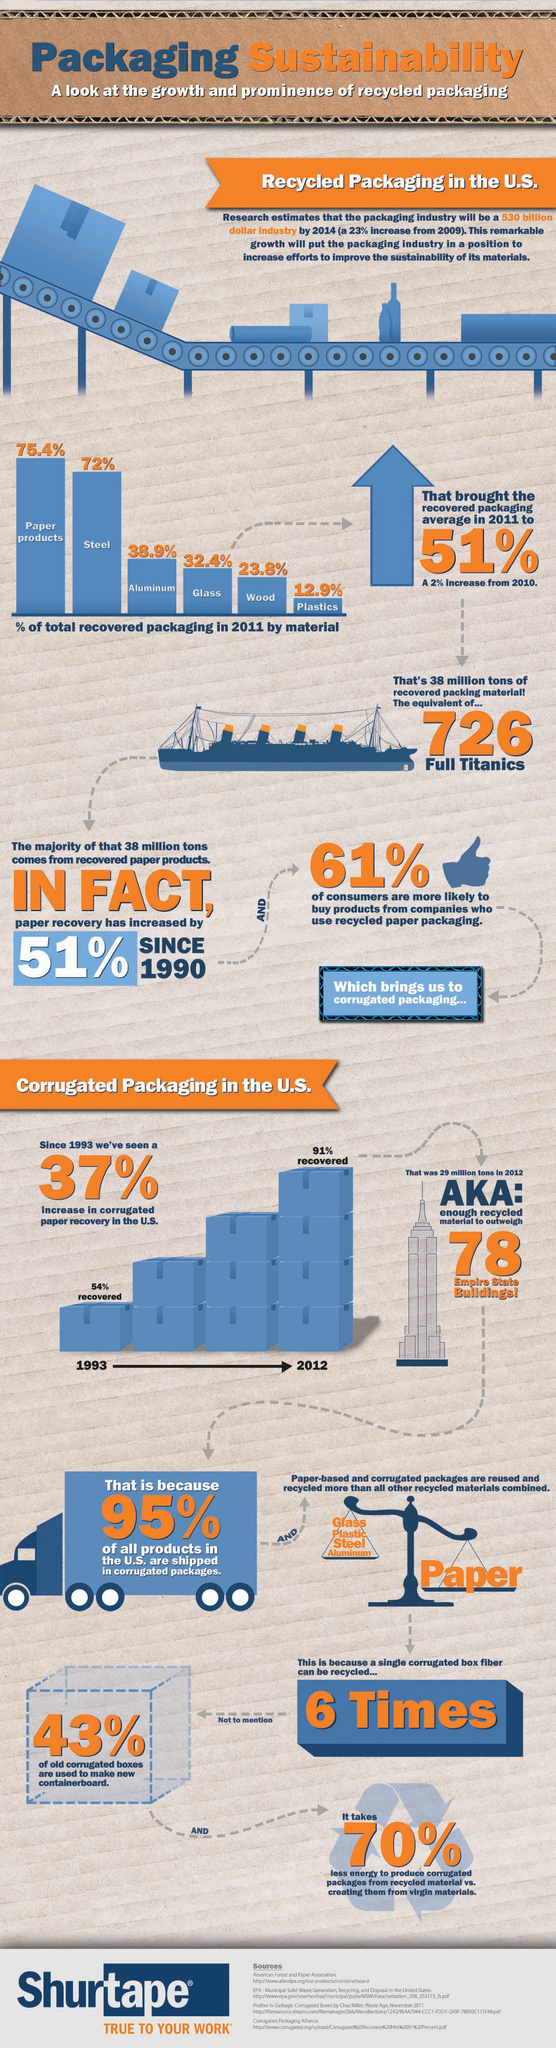What percentage of corrugated paper recovery was made in U.S. in 1993?
Answer the question with a short phrase. 54% What is the percentage of total recovered packaging of paper products in the U.S. in 2011? 75.4% How many times a single corrugated box fiber can be recycled? 6 Times Which material has the lowest percentage of total recovered packaging in the U.S. in 2011? Plasctics What percentage of corrugated paper recovery was made in U.S. in 2012? 91% What percentage of all products in the U.S. are not shipped in corrugated packages? 5% What percentage of consumers do not intend to buy products from companies who use recycled paper packaging in U.S in 2011? 39% What percentage of total recovered packaging is Aluminium in the U.S. in 2011? 38.9% What percentage of total recovered packaging is steel in the U.S. in 2011? 72% Which material has the highest percentage of total recovered packaging in the U.S. in 2011? Paper products 